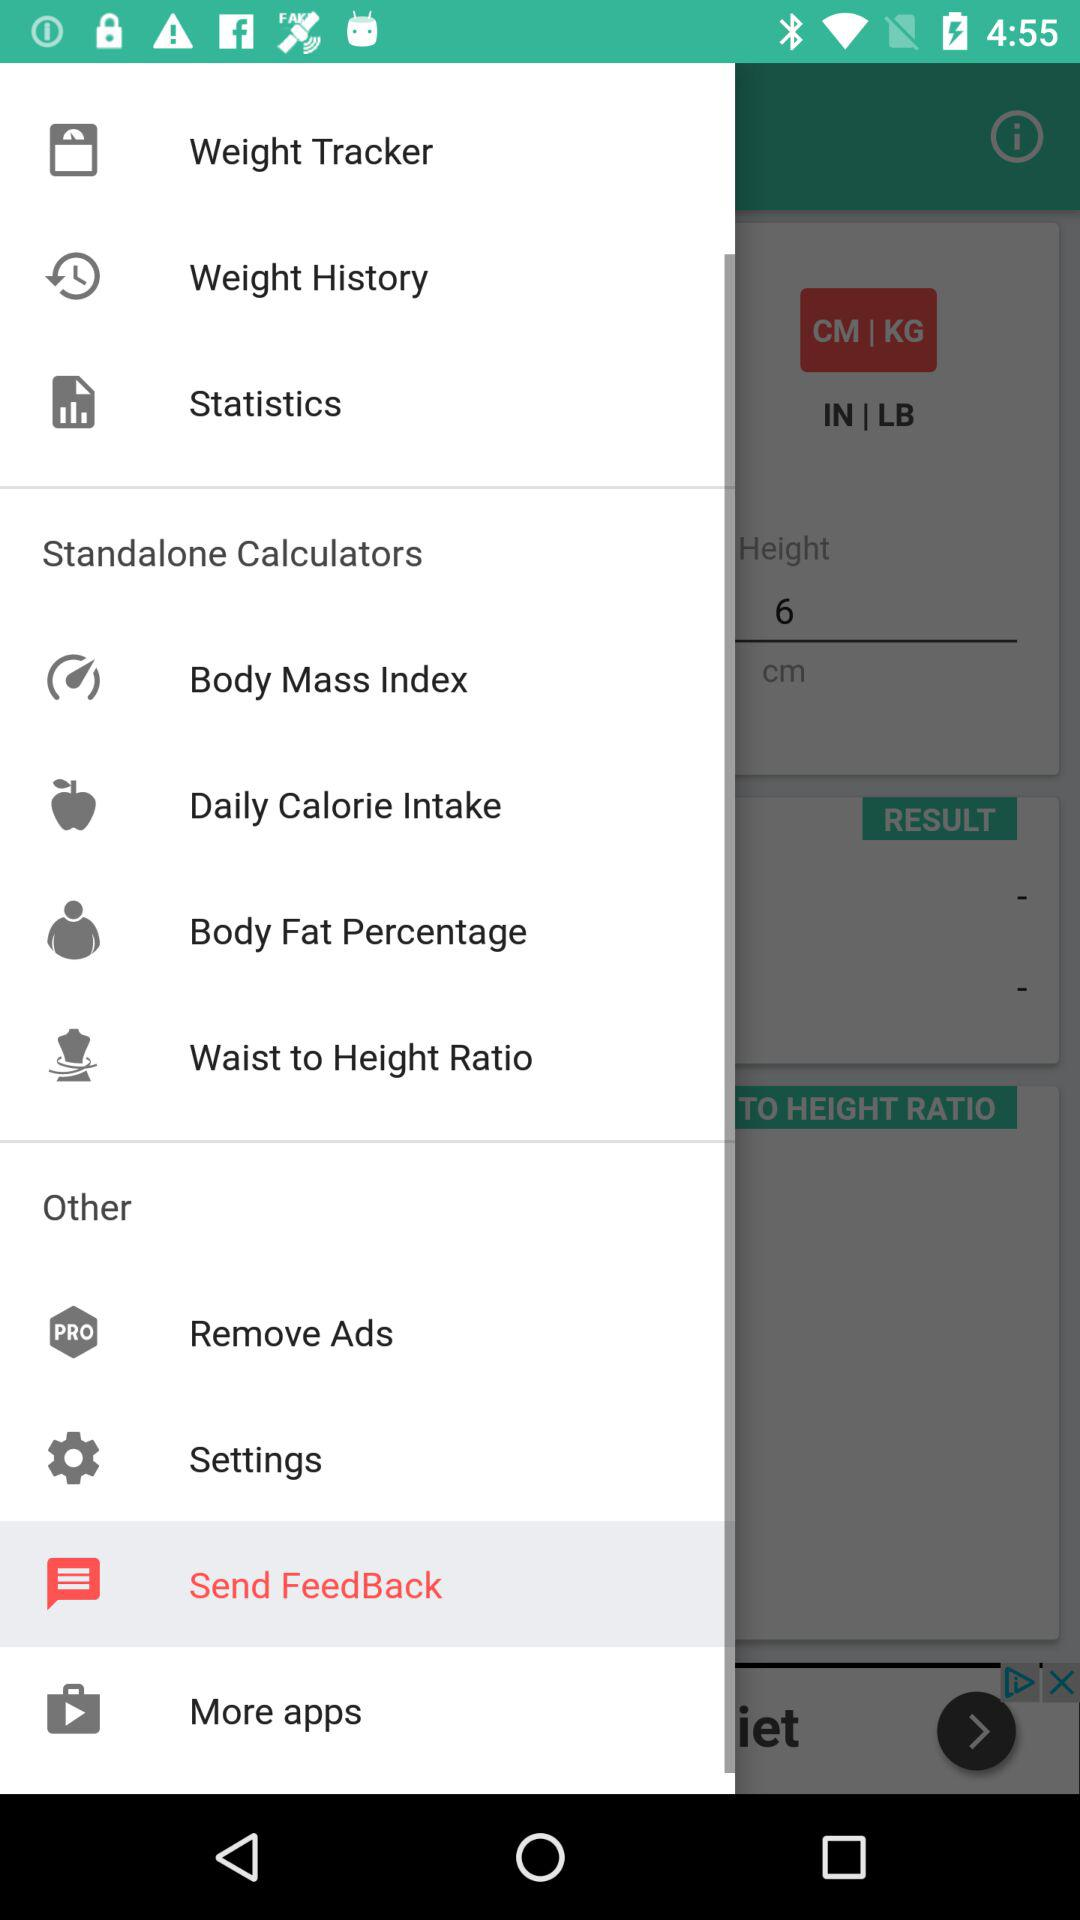Which option is selected? The selected option is "Send Feedback". 